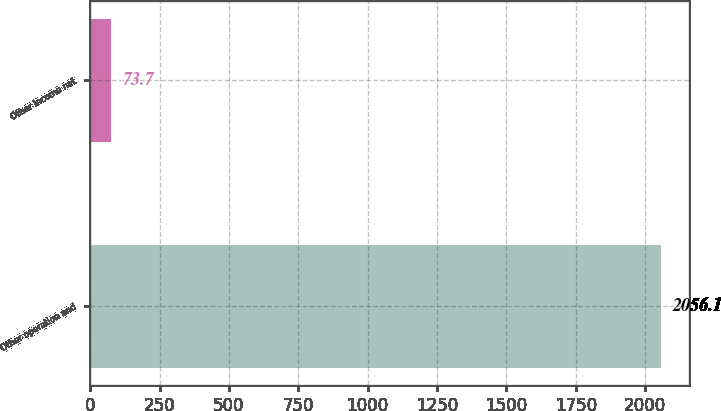Convert chart. <chart><loc_0><loc_0><loc_500><loc_500><bar_chart><fcel>Other operation and<fcel>Other income net<nl><fcel>2056.1<fcel>73.7<nl></chart> 